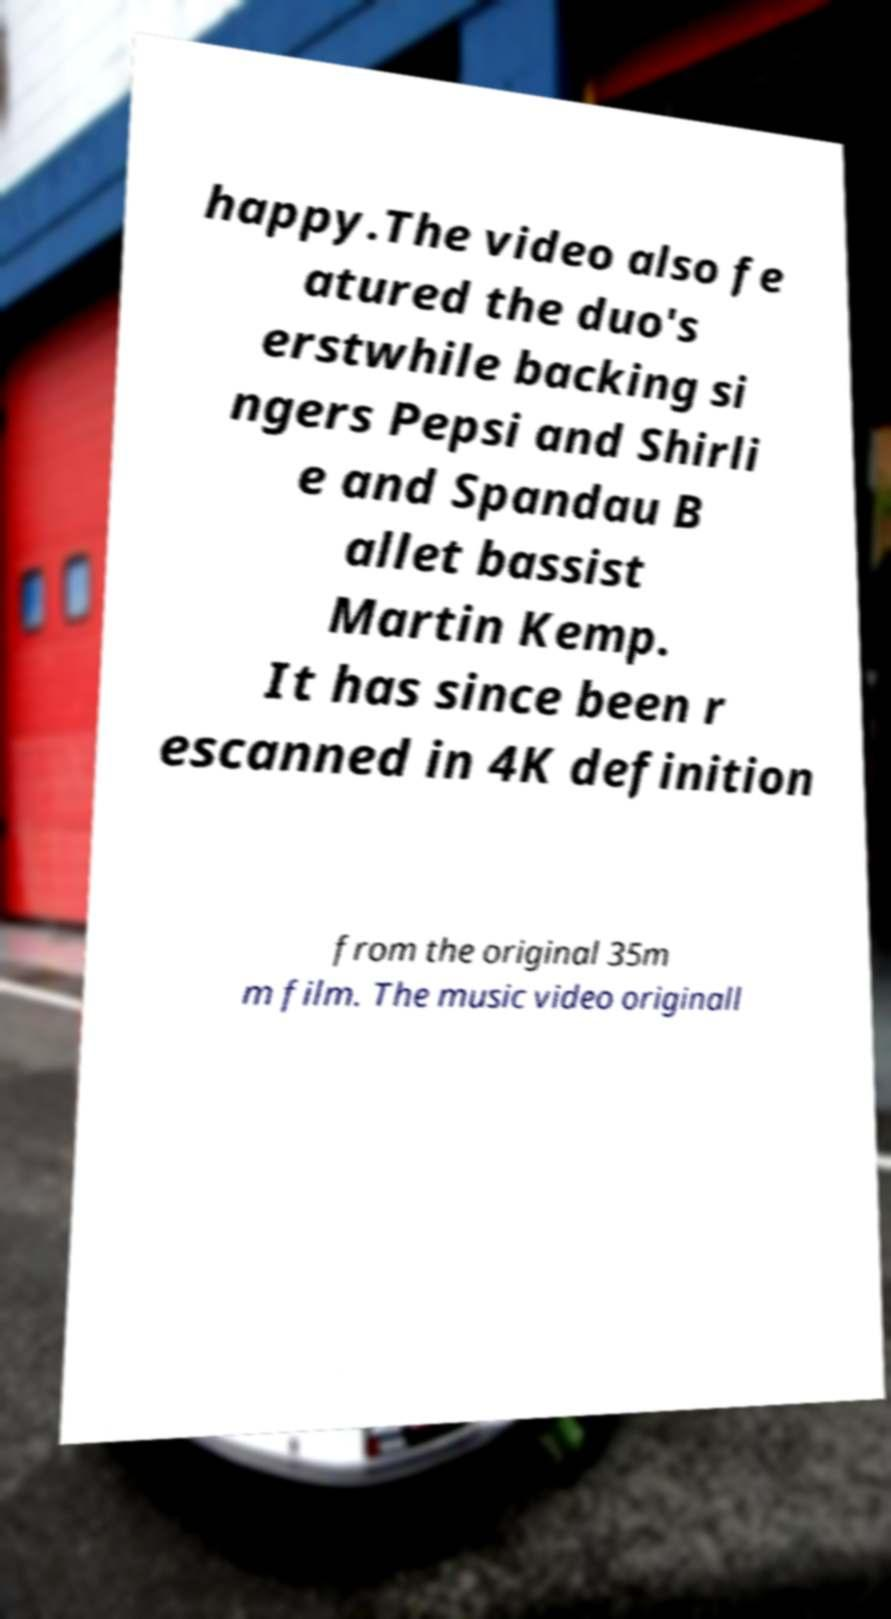Could you extract and type out the text from this image? happy.The video also fe atured the duo's erstwhile backing si ngers Pepsi and Shirli e and Spandau B allet bassist Martin Kemp. It has since been r escanned in 4K definition from the original 35m m film. The music video originall 